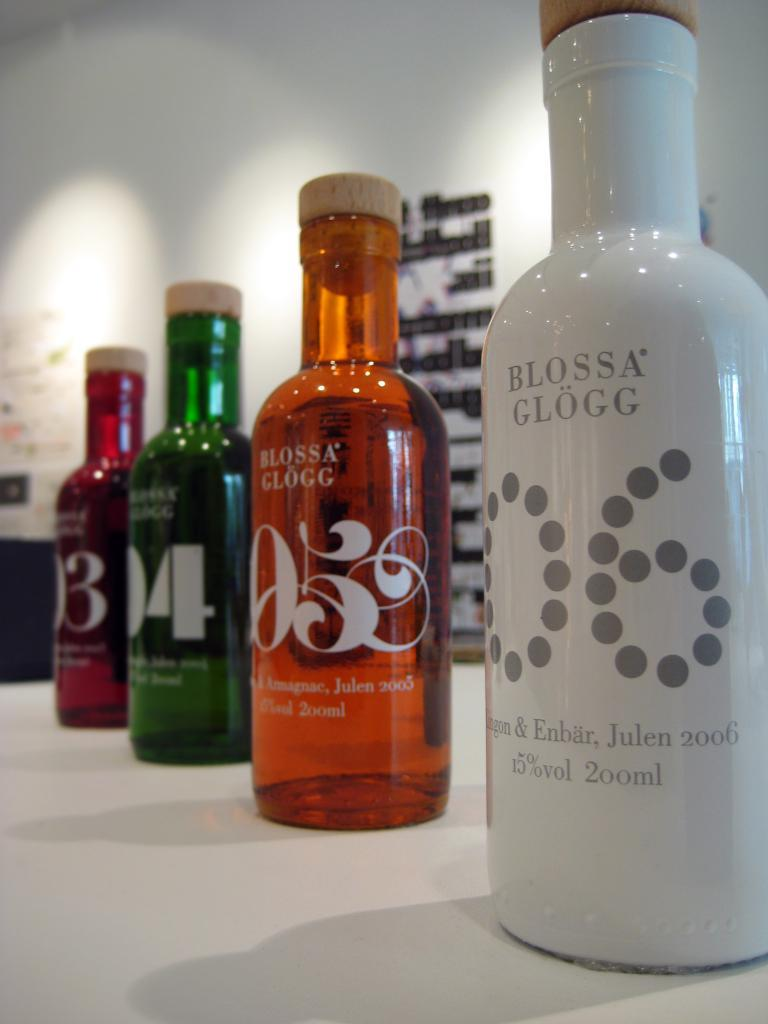<image>
Share a concise interpretation of the image provided. Four bottles of Blossa Glogg are lined up on a table, all different colors. 